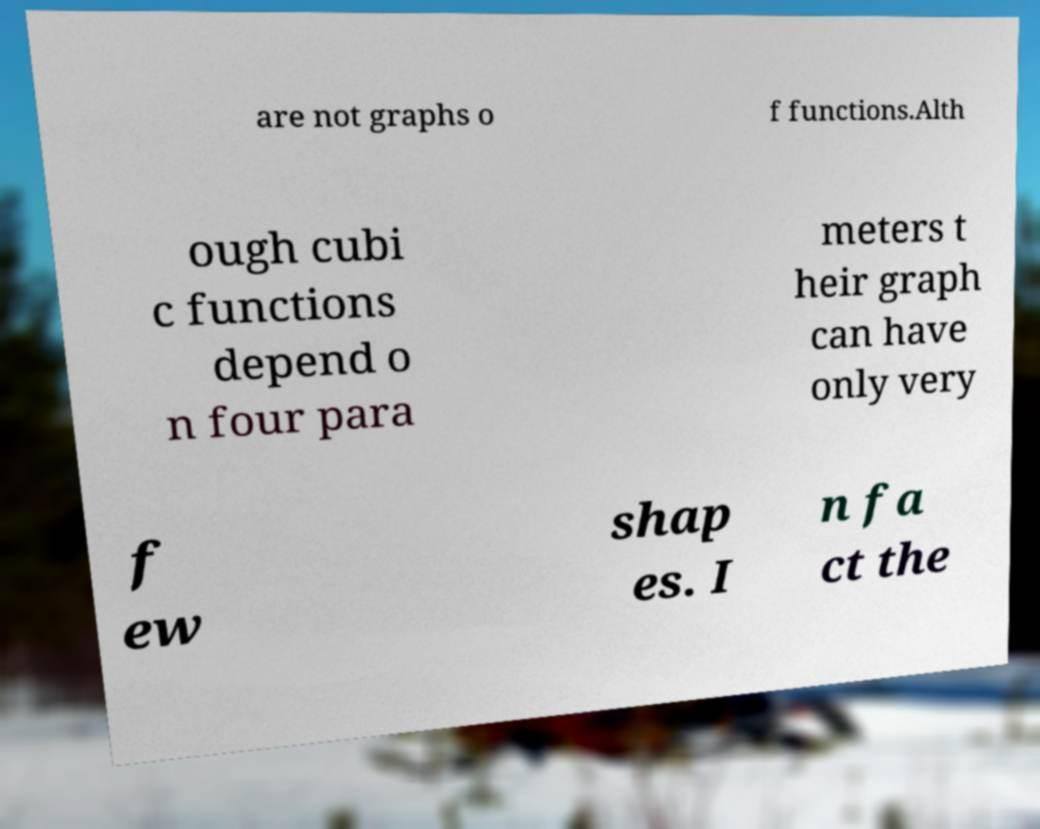Could you extract and type out the text from this image? are not graphs o f functions.Alth ough cubi c functions depend o n four para meters t heir graph can have only very f ew shap es. I n fa ct the 